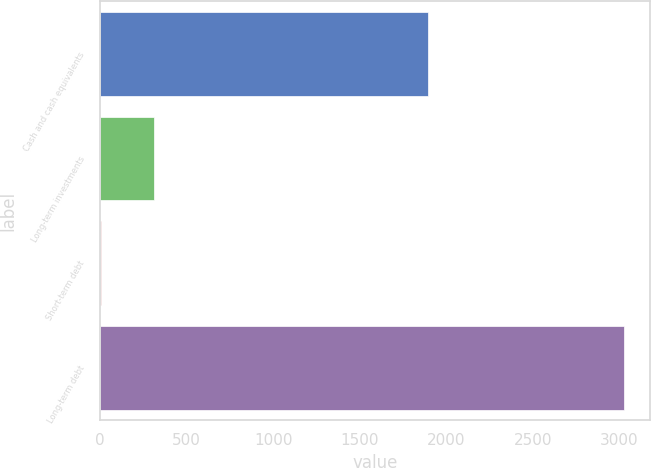Convert chart. <chart><loc_0><loc_0><loc_500><loc_500><bar_chart><fcel>Cash and cash equivalents<fcel>Long-term investments<fcel>Short-term debt<fcel>Long-term debt<nl><fcel>1894<fcel>309.8<fcel>8<fcel>3026<nl></chart> 